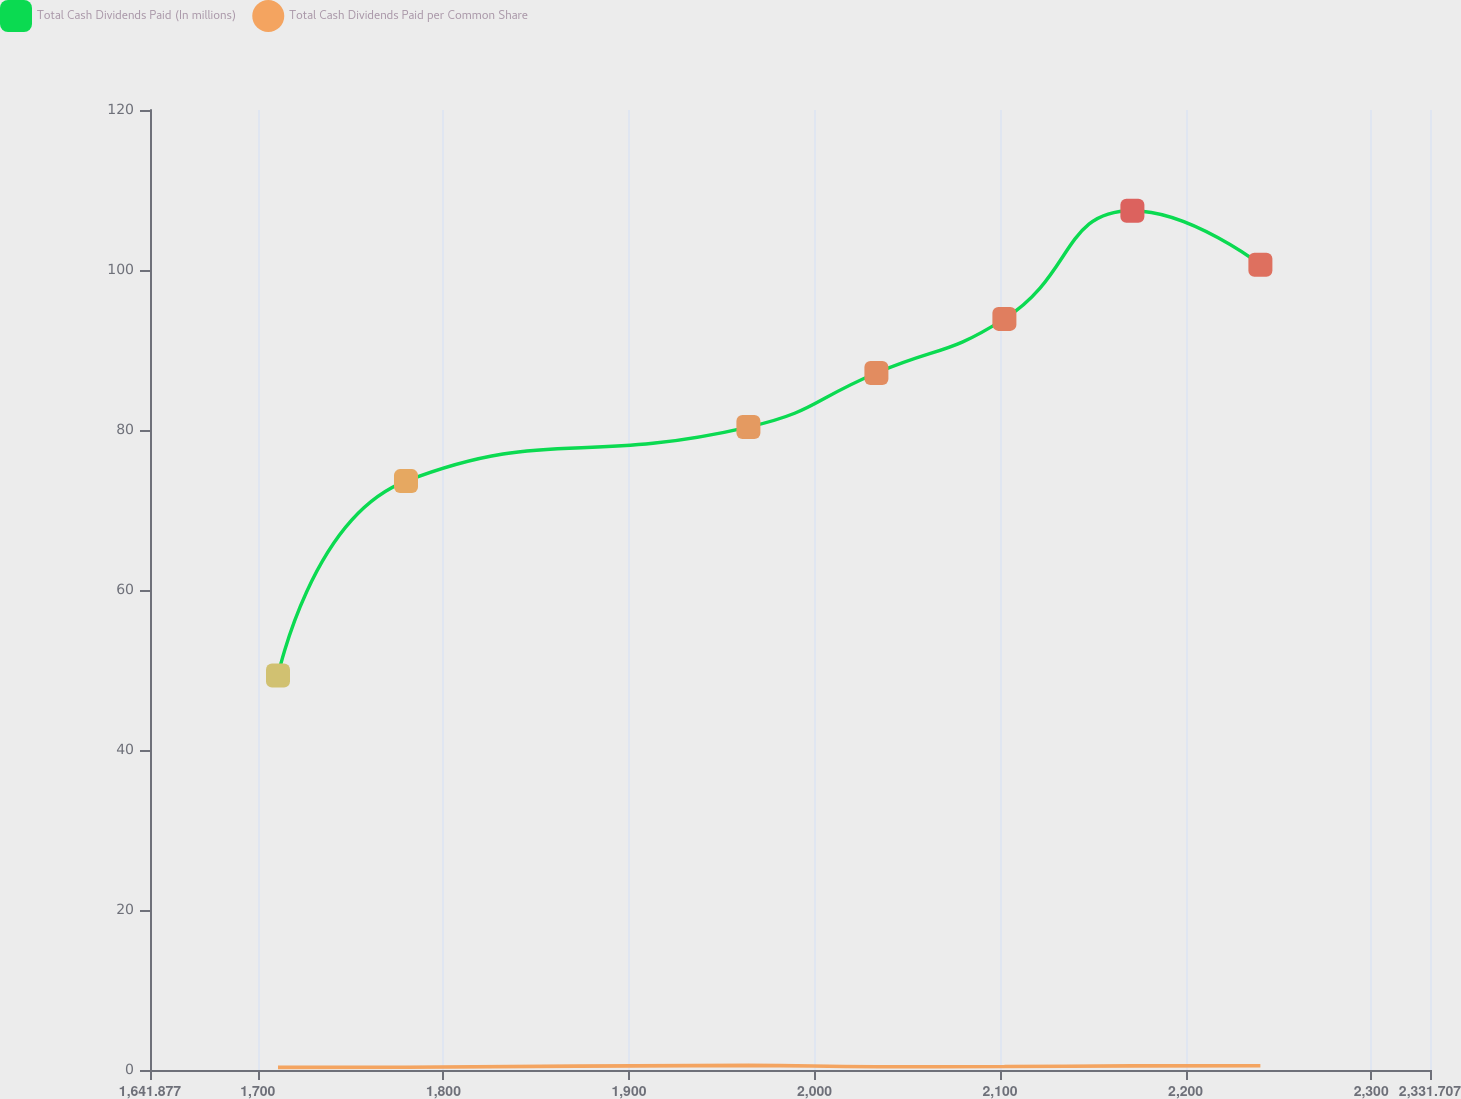Convert chart. <chart><loc_0><loc_0><loc_500><loc_500><line_chart><ecel><fcel>Total Cash Dividends Paid (In millions)<fcel>Total Cash Dividends Paid per Common Share<nl><fcel>1710.86<fcel>49.31<fcel>0.33<nl><fcel>1779.84<fcel>73.61<fcel>0.35<nl><fcel>1964.38<fcel>80.37<fcel>0.58<nl><fcel>2033.36<fcel>87.13<fcel>0.41<nl><fcel>2102.34<fcel>93.89<fcel>0.43<nl><fcel>2171.32<fcel>107.41<fcel>0.52<nl><fcel>2240.3<fcel>100.65<fcel>0.54<nl><fcel>2400.69<fcel>116.87<fcel>0.56<nl></chart> 